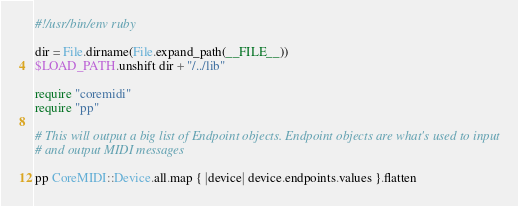<code> <loc_0><loc_0><loc_500><loc_500><_Ruby_>#!/usr/bin/env ruby

dir = File.dirname(File.expand_path(__FILE__))
$LOAD_PATH.unshift dir + "/../lib"

require "coremidi"
require "pp"

# This will output a big list of Endpoint objects. Endpoint objects are what's used to input
# and output MIDI messages

pp CoreMIDI::Device.all.map { |device| device.endpoints.values }.flatten
</code> 